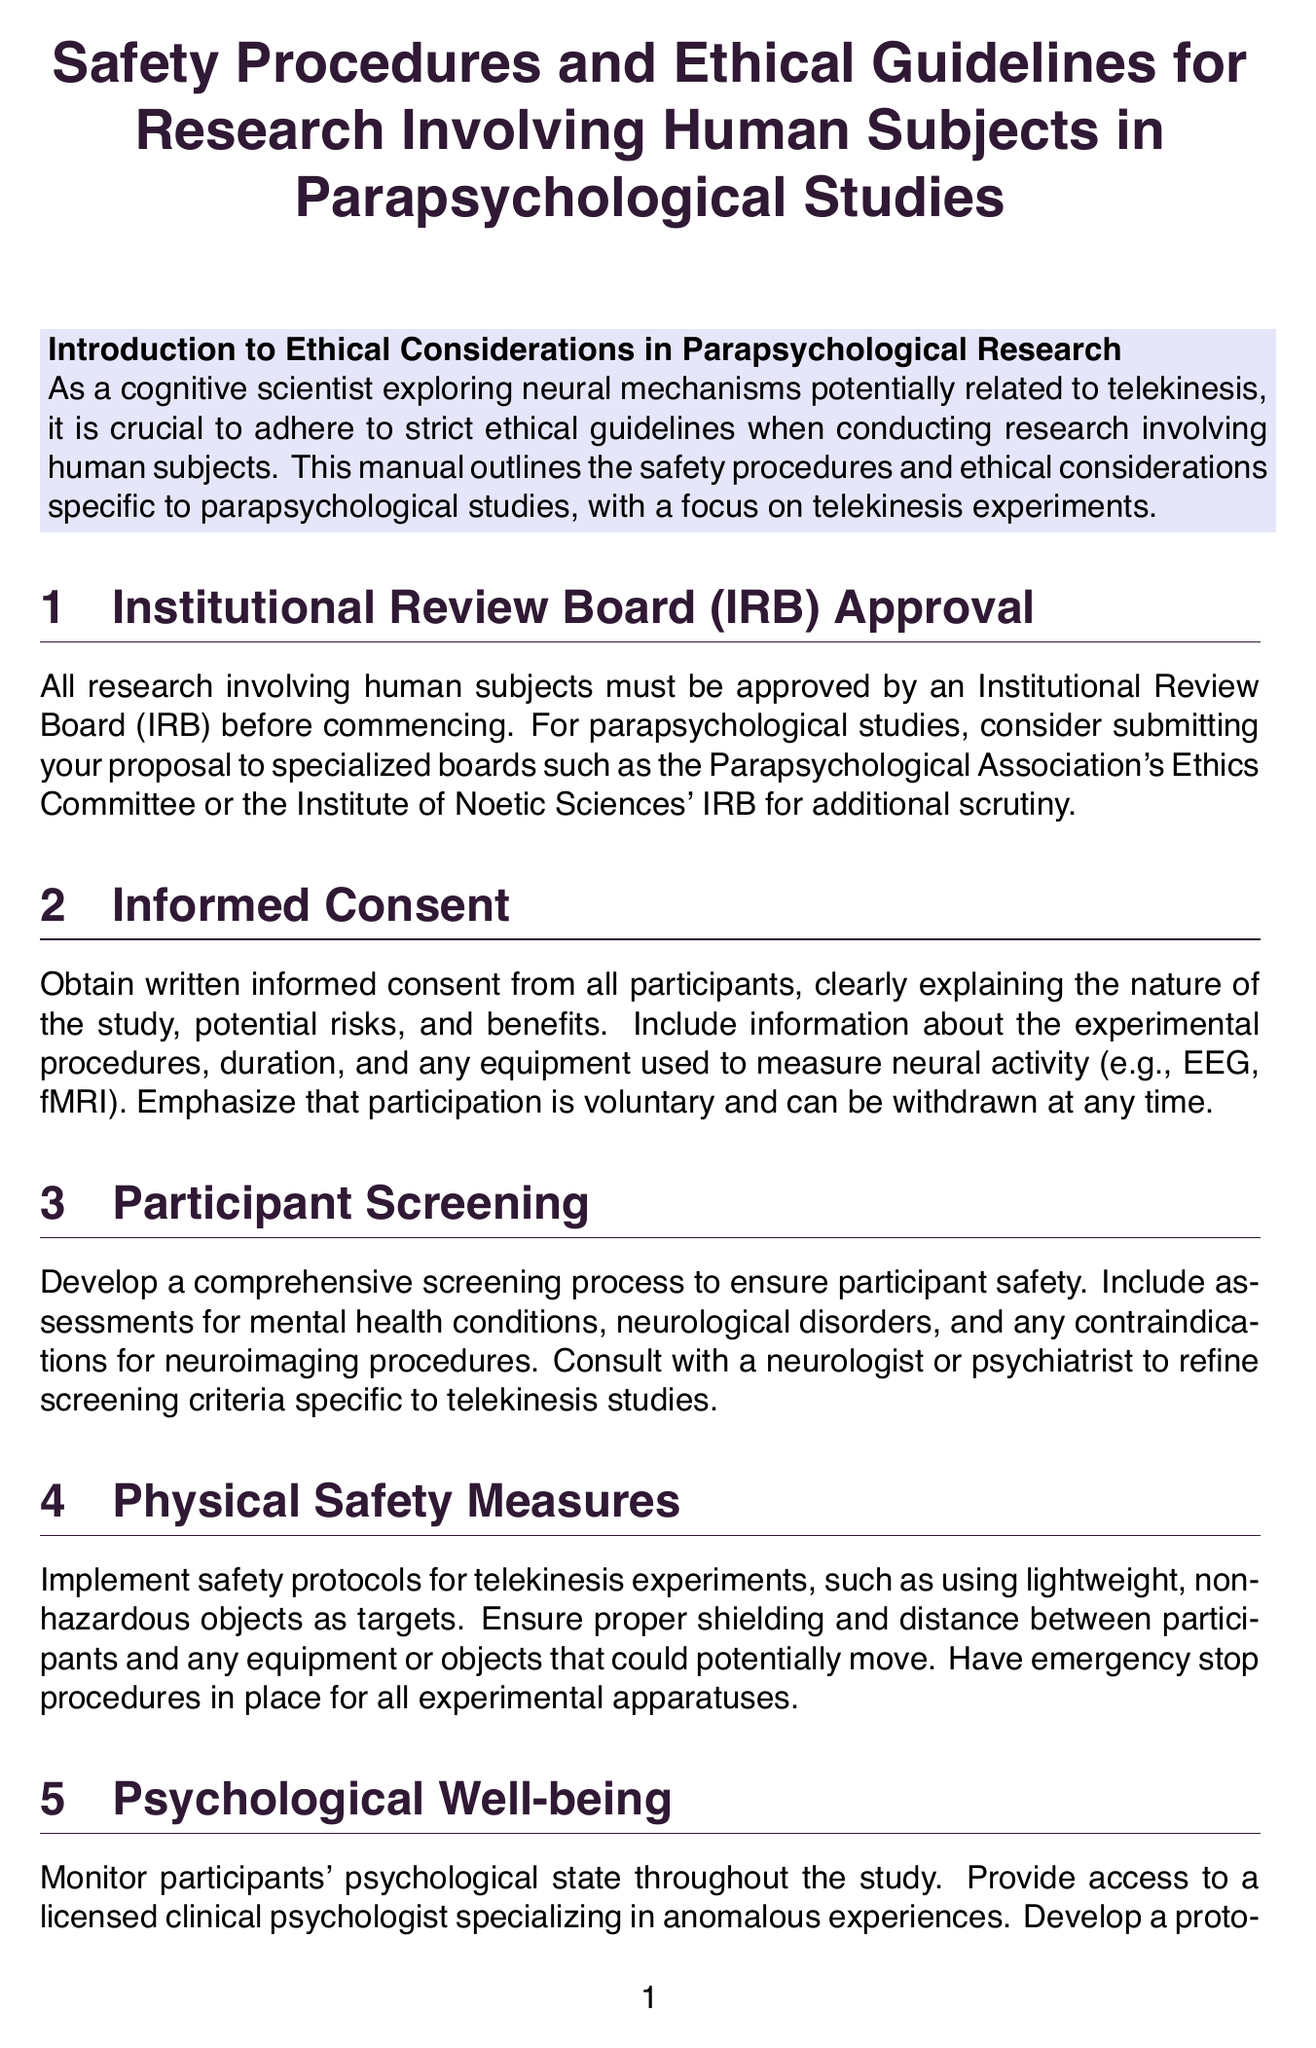What is the title of the manual? The title is stated at the beginning of the document as the main heading.
Answer: Safety Procedures and Ethical Guidelines for Research Involving Human Subjects in Parapsychological Studies What must all research involving human subjects have before commencing? This information is found in the section discussing the IRB approval process.
Answer: IRB approval Which committee is suggested for submitting proposals for parapsychological studies? This is mentioned in the section on Institutional Review Board approval.
Answer: Parapsychological Association's Ethics Committee What is required from participants regarding consent? The document outlines the informed consent procedures for participant engagement.
Answer: Written informed consent What should be monitored throughout the study according to the manual? This is specified in the section regarding participants' well-being.
Answer: Participants' psychological state What type of professionals should be consulted for the participant screening process? The document refers to specific professionals who should help with screening.
Answer: Neurologist or psychiatrist What does the manual advise regarding data protection? This is highlighted in the section dedicated to safeguarding participant information.
Answer: Robust data protection measures What should be done after each experiment with participants? This is discussed in the debriefing section of the manual.
Answer: Thorough debriefing sessions What is the recommended approach to report results of the study? This is stated in the section about reporting ethics within the manual.
Answer: Adhere to the highest standards of scientific integrity 